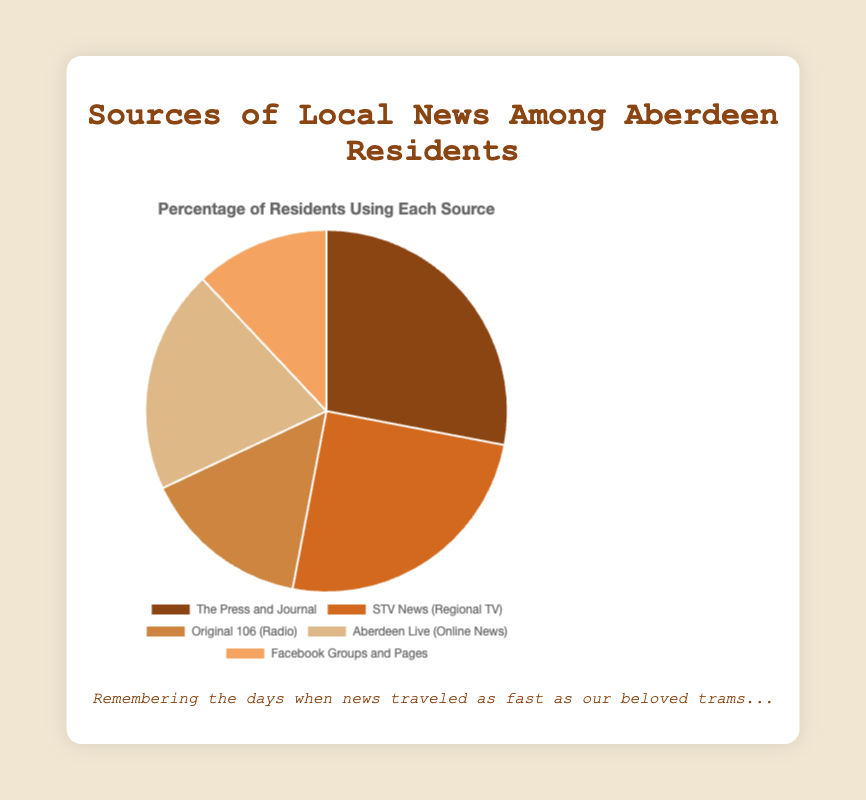Which source of local news is the least popular among Aberdeen residents? By examining the chart, we see that the segment with the smallest size represents "Facebook Groups and Pages" at 12%. Therefore, "Facebook Groups and Pages" is the least popular source of local news among Aberdeen residents.
Answer: Facebook Groups and Pages What is the combined percentage of residents who get their news from online sources? The online sources in the chart are "Aberdeen Live (Online News)" at 20% and "Facebook Groups and Pages" at 12%. Adding these together gives 20% + 12% = 32%.
Answer: 32% How does the popularity of radio compare to that of TV among Aberdeen residents? The chart shows "Original 106 (Radio)" at 15% and "STV News (Regional TV)" at 25%. Comparison reveals that TV is more popular than radio by 25% - 15% = 10%.
Answer: TV is more popular by 10% If we combine the percentages for newspapers and TV, what fraction of Aberdeen residents use these sources for local news? The chart shows "The Press and Journal" at 28% and "STV News (Regional TV)" at 25%. Adding these percentages together results in 28% + 25% = 53%.
Answer: 53% Which source has the nearest percentage to 20%, and what are they? According to the chart, "Aberdeen Live (Online News)" has a percentage of 20%, which matches exactly. Therefore, it is the source nearest to 20%.
Answer: Aberdeen Live (Online News) If we exclude the most popular and least popular sources, what is the total percentage of the remaining sources? Excluding "The Press and Journal" (28%) and "Facebook Groups and Pages" (12%), the remaining sources are "STV News (Regional TV)" (25%), "Original 106 (Radio)" (15%), and "Aberdeen Live (Online News)" (20%). Adding these together gives 25% + 15% + 20% = 60%.
Answer: 60% Which visual segment represents "The Press and Journal," and what is its color? "The Press and Journal" has the largest segment at 28%. According to the defined colors, it is represented by the color closest to a deep brown shade.
Answer: Deep brown What is the difference in percentage between online news sources and traditional news media (newspapers, TV, radio)? Online news sources are "Aberdeen Live (Online News)" at 20% and "Facebook Groups and Pages" at 12%, summing to 32%. Traditional media are "The Press and Journal" (28%), "STV News (Regional TV)" (25%), and "Original 106 (Radio)" (15%), summing to 28% + 25% + 15% = 68%. The difference is 68% - 32% = 36%.
Answer: 36% Is the percentage of residents who get their news from newspapers greater than the combined percentage of those who use Facebook Groups and Original 106? The percentage for "The Press and Journal" is 28%. The combined percentage for "Facebook Groups and Pages" (12%) and "Original 106 (Radio)" (15%) is 12% + 15% = 27%. Since 28% is greater than 27%, the answer is yes.
Answer: Yes 